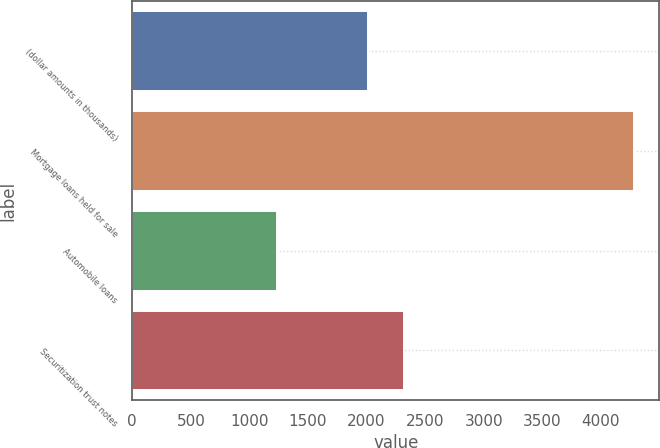Convert chart. <chart><loc_0><loc_0><loc_500><loc_500><bar_chart><fcel>(dollar amounts in thousands)<fcel>Mortgage loans held for sale<fcel>Automobile loans<fcel>Securitization trust notes<nl><fcel>2012<fcel>4284<fcel>1231<fcel>2317.3<nl></chart> 